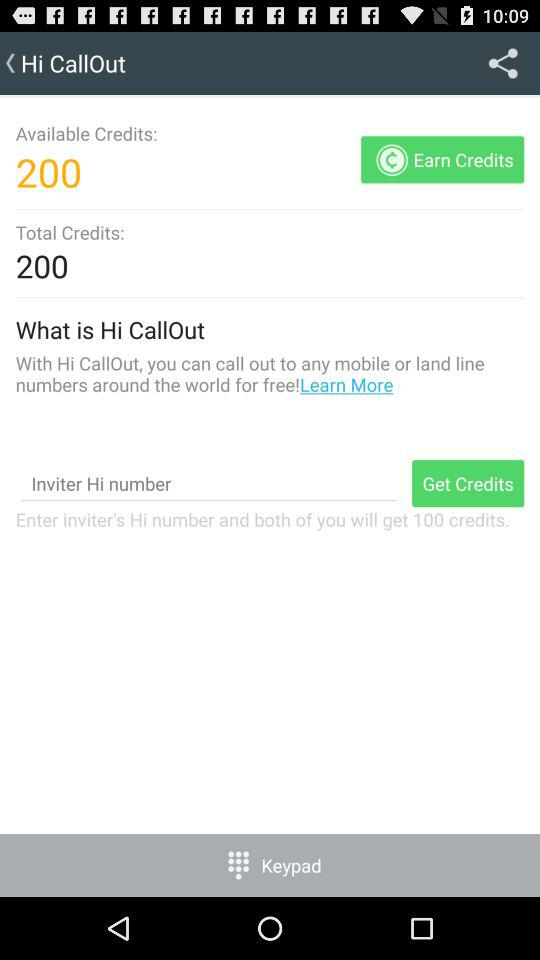What is the total credit? The total credit is 200. 